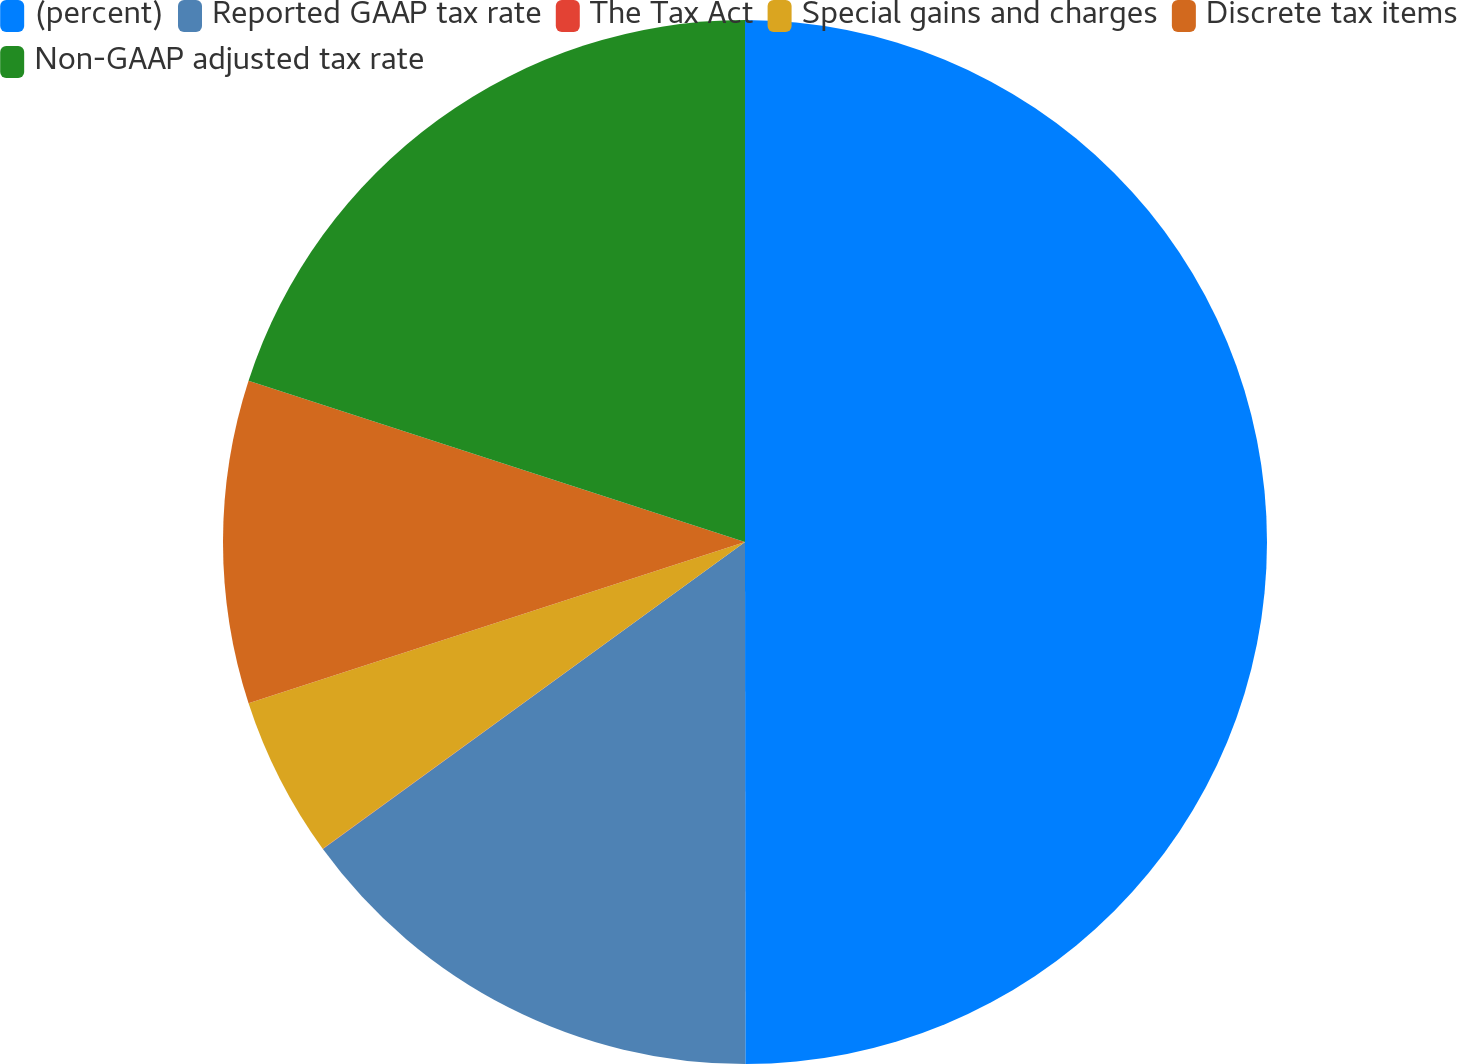Convert chart. <chart><loc_0><loc_0><loc_500><loc_500><pie_chart><fcel>(percent)<fcel>Reported GAAP tax rate<fcel>The Tax Act<fcel>Special gains and charges<fcel>Discrete tax items<fcel>Non-GAAP adjusted tax rate<nl><fcel>49.99%<fcel>15.0%<fcel>0.01%<fcel>5.0%<fcel>10.0%<fcel>20.0%<nl></chart> 